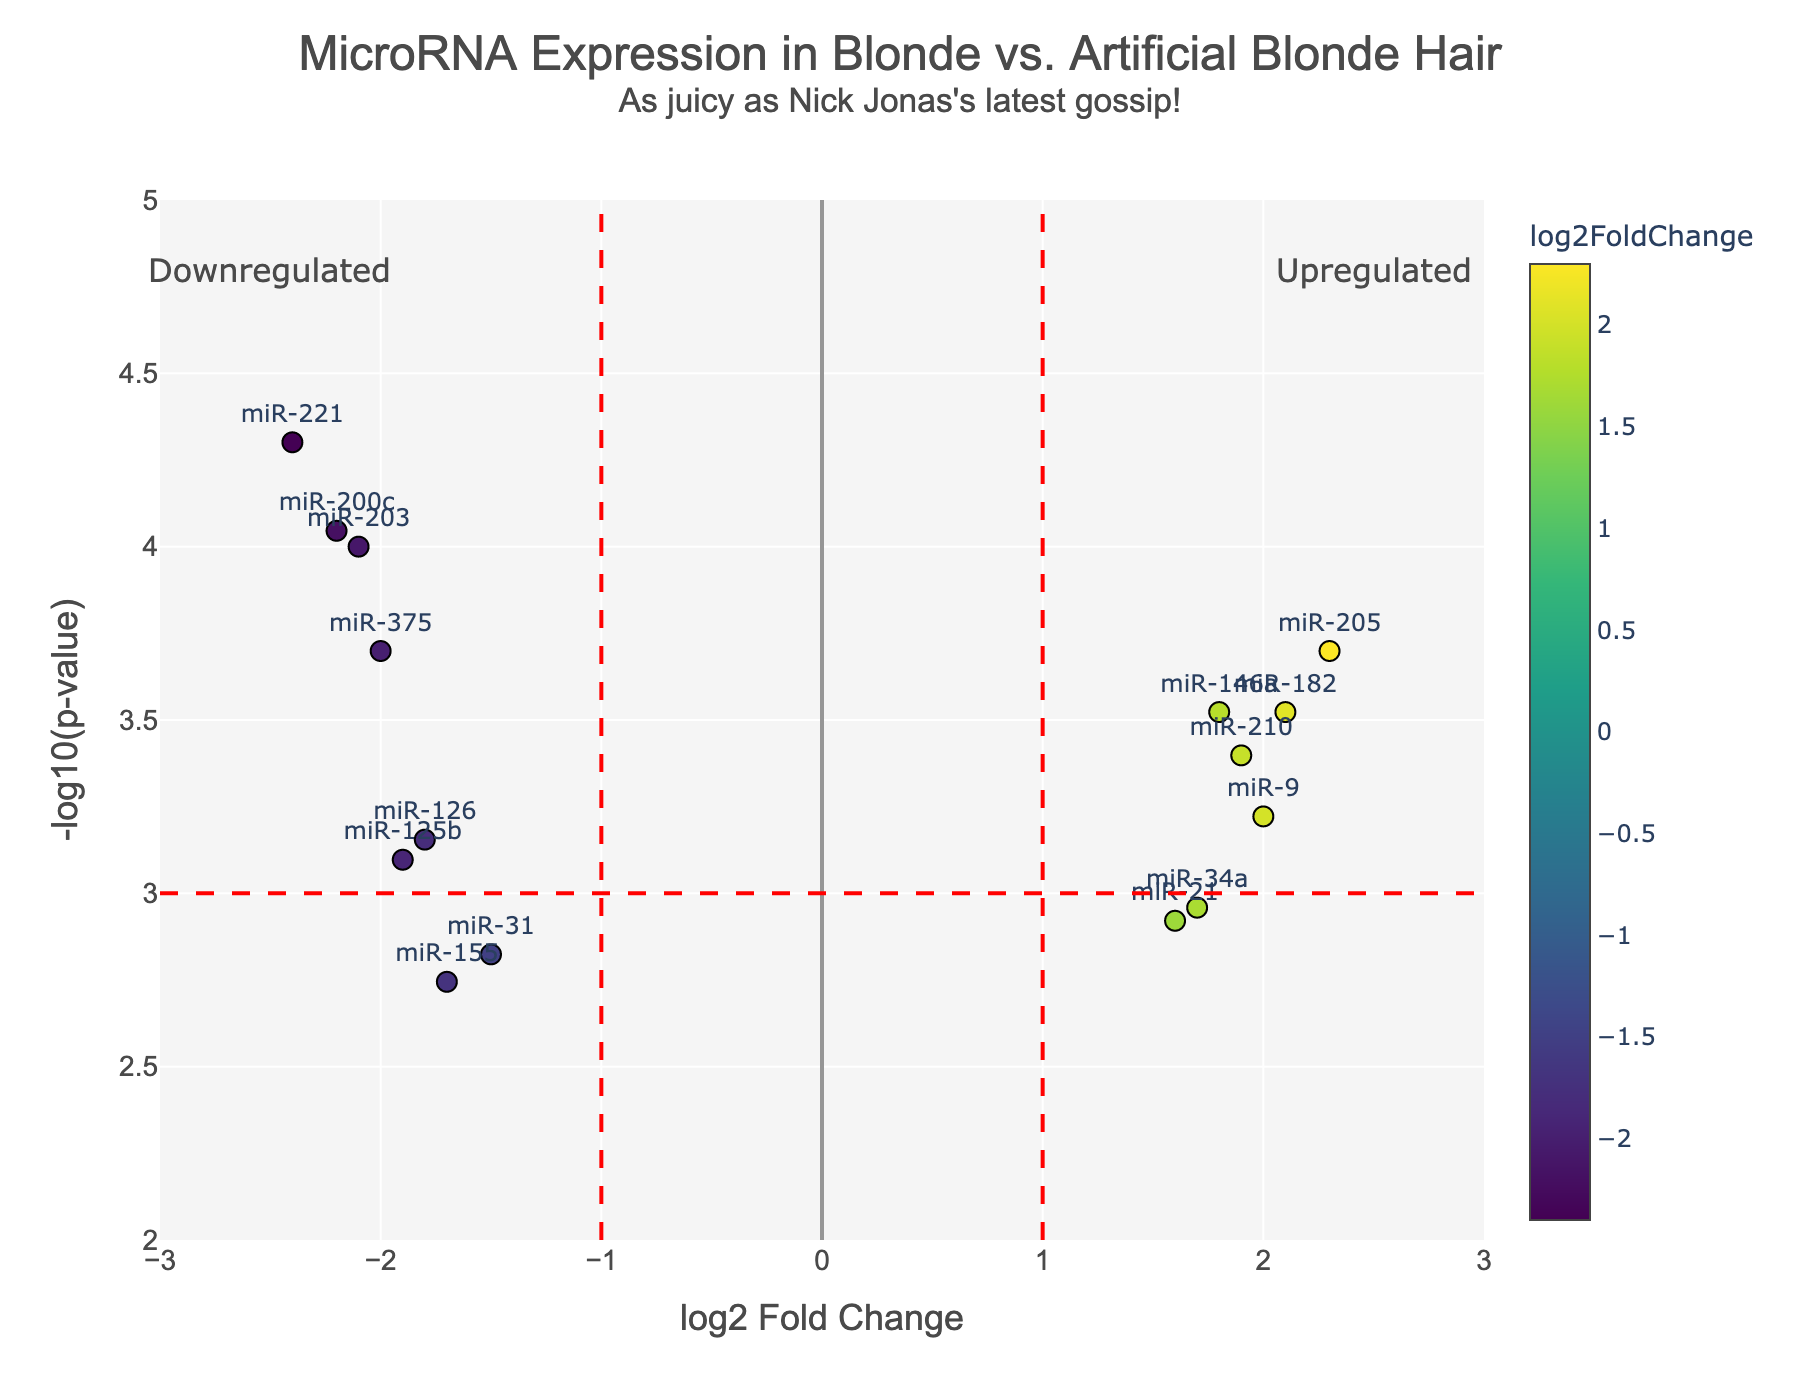What is the title of this plot? The title is placed at the top of the graph and indicates the subject of the plot with a playful subtitle mentioning Nick Jonas.
Answer: MicroRNA Expression in Blonde vs. Artificial Blonde Hair How many miRNAs are significantly upregulated (log2FoldChange > 1 and p-value < 0.001)? Count the data points in the right half of the plot above the red significance line indicating p-value < 0.001.
Answer: 3 Which miRNA has the lowest p-value, and what is its log2FoldChange? Identify the miRNA with the highest -log10(p-value) in the plot and note its log2FoldChange.
Answer: miR-221, -2.4 What is the log2FoldChange range displayed in this plot? Check the x-axis range that is provided in the plot settings. The range spans from -3 to 3 as indicated by the x-axis settings.
Answer: -3 to 3 Which miRNA is plotted furthest to the right, and is it upregulated or downregulated? Locate the miRNA on the farthest right end along the x-axis (positive direction) and check its log2FoldChange.
Answer: miR-205, upregulated How does miR-375 compare to miR-210 in terms of both log2FoldChange and p-value? Compare both miRNAs based on their position on the x-axis (log2FoldChange) and y-axis (-log10(p-value)). miR-375 has a more negative log2FoldChange, indicating downregulation, while miR-210 has a positive log2FoldChange, indicating upregulation.
Answer: miR-375: downregulated, miR-210: upregulated What is the -log10(p-value) of miR-31? Identify the miRNA on the plot and read its position along the y-axis.
Answer: ~2.82 If an miRNA has a log2FoldChange of zero, what does it indicate about its expression? A log2FoldChange of zero means there is no difference in expression between naturally blonde and artificially blonde actresses.
Answer: No expression difference Can you name a highly upregulated miRNA and its corresponding log2FoldChange and p-value? Look for miRNAs on the extreme right of the plot, with high values on the y-axis.
Answer: miR-205, log2FoldChange: 2.3, p-value: 0.0002 What's the significance threshold for -log10(p-value) in this plot? Check the red horizontal line which indicates the significance threshold for -log10(p-value).
Answer: 3 Which side (left or right of the y-axis) represents downregulated miRNAs? The left side (negative log2FoldChange) represents downregulated miRNAs.
Answer: Left 